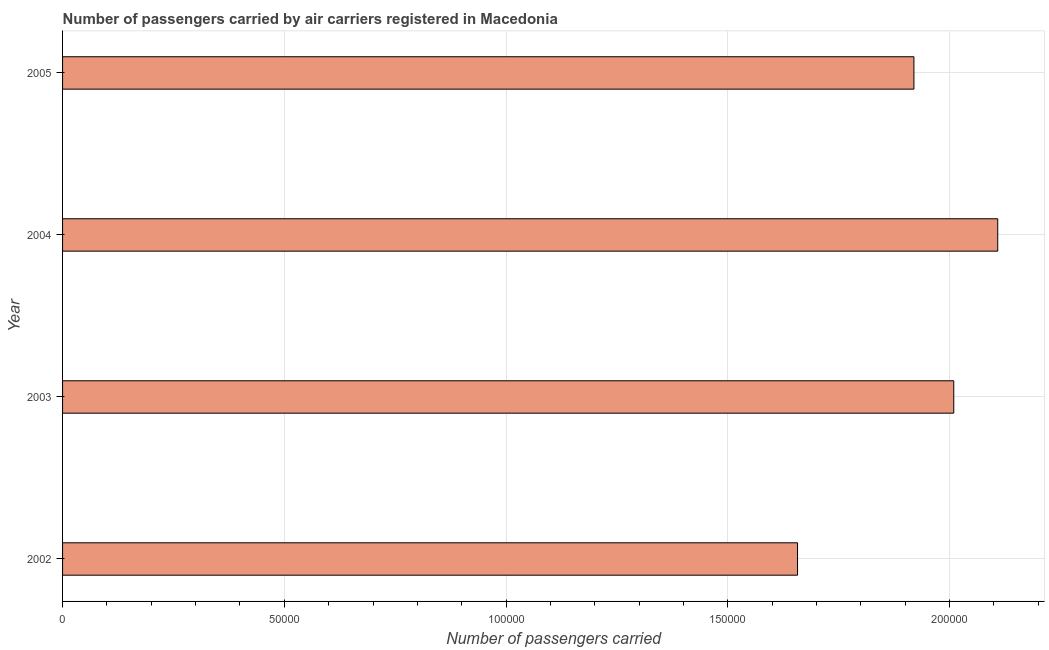Does the graph contain any zero values?
Provide a short and direct response. No. What is the title of the graph?
Provide a short and direct response. Number of passengers carried by air carriers registered in Macedonia. What is the label or title of the X-axis?
Keep it short and to the point. Number of passengers carried. What is the number of passengers carried in 2003?
Provide a succinct answer. 2.01e+05. Across all years, what is the maximum number of passengers carried?
Ensure brevity in your answer.  2.11e+05. Across all years, what is the minimum number of passengers carried?
Offer a terse response. 1.66e+05. In which year was the number of passengers carried maximum?
Offer a terse response. 2004. What is the sum of the number of passengers carried?
Your answer should be very brief. 7.70e+05. What is the difference between the number of passengers carried in 2004 and 2005?
Offer a terse response. 1.89e+04. What is the average number of passengers carried per year?
Your answer should be very brief. 1.92e+05. What is the median number of passengers carried?
Offer a terse response. 1.96e+05. In how many years, is the number of passengers carried greater than 180000 ?
Keep it short and to the point. 3. Do a majority of the years between 2002 and 2004 (inclusive) have number of passengers carried greater than 70000 ?
Provide a short and direct response. Yes. What is the ratio of the number of passengers carried in 2004 to that in 2005?
Keep it short and to the point. 1.1. Is the difference between the number of passengers carried in 2003 and 2004 greater than the difference between any two years?
Keep it short and to the point. No. What is the difference between the highest and the second highest number of passengers carried?
Keep it short and to the point. 9916. What is the difference between the highest and the lowest number of passengers carried?
Ensure brevity in your answer.  4.51e+04. In how many years, is the number of passengers carried greater than the average number of passengers carried taken over all years?
Make the answer very short. 2. How many bars are there?
Ensure brevity in your answer.  4. Are the values on the major ticks of X-axis written in scientific E-notation?
Keep it short and to the point. No. What is the Number of passengers carried in 2002?
Make the answer very short. 1.66e+05. What is the Number of passengers carried in 2003?
Offer a terse response. 2.01e+05. What is the Number of passengers carried in 2004?
Give a very brief answer. 2.11e+05. What is the Number of passengers carried in 2005?
Provide a short and direct response. 1.92e+05. What is the difference between the Number of passengers carried in 2002 and 2003?
Give a very brief answer. -3.52e+04. What is the difference between the Number of passengers carried in 2002 and 2004?
Offer a very short reply. -4.51e+04. What is the difference between the Number of passengers carried in 2002 and 2005?
Keep it short and to the point. -2.62e+04. What is the difference between the Number of passengers carried in 2003 and 2004?
Ensure brevity in your answer.  -9916. What is the difference between the Number of passengers carried in 2003 and 2005?
Ensure brevity in your answer.  8982. What is the difference between the Number of passengers carried in 2004 and 2005?
Keep it short and to the point. 1.89e+04. What is the ratio of the Number of passengers carried in 2002 to that in 2003?
Give a very brief answer. 0.82. What is the ratio of the Number of passengers carried in 2002 to that in 2004?
Offer a very short reply. 0.79. What is the ratio of the Number of passengers carried in 2002 to that in 2005?
Give a very brief answer. 0.86. What is the ratio of the Number of passengers carried in 2003 to that in 2004?
Your answer should be compact. 0.95. What is the ratio of the Number of passengers carried in 2003 to that in 2005?
Your answer should be very brief. 1.05. What is the ratio of the Number of passengers carried in 2004 to that in 2005?
Keep it short and to the point. 1.1. 